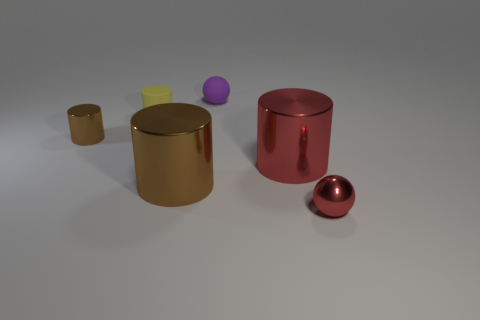Subtract all large brown shiny cylinders. How many cylinders are left? 3 Add 2 metallic cylinders. How many objects exist? 8 Subtract all purple balls. How many balls are left? 1 Subtract all cylinders. How many objects are left? 2 Subtract 0 green spheres. How many objects are left? 6 Subtract all brown cylinders. Subtract all red cubes. How many cylinders are left? 2 Subtract all yellow blocks. How many purple balls are left? 1 Subtract all red objects. Subtract all red shiny objects. How many objects are left? 2 Add 6 big brown cylinders. How many big brown cylinders are left? 7 Add 3 green matte blocks. How many green matte blocks exist? 3 